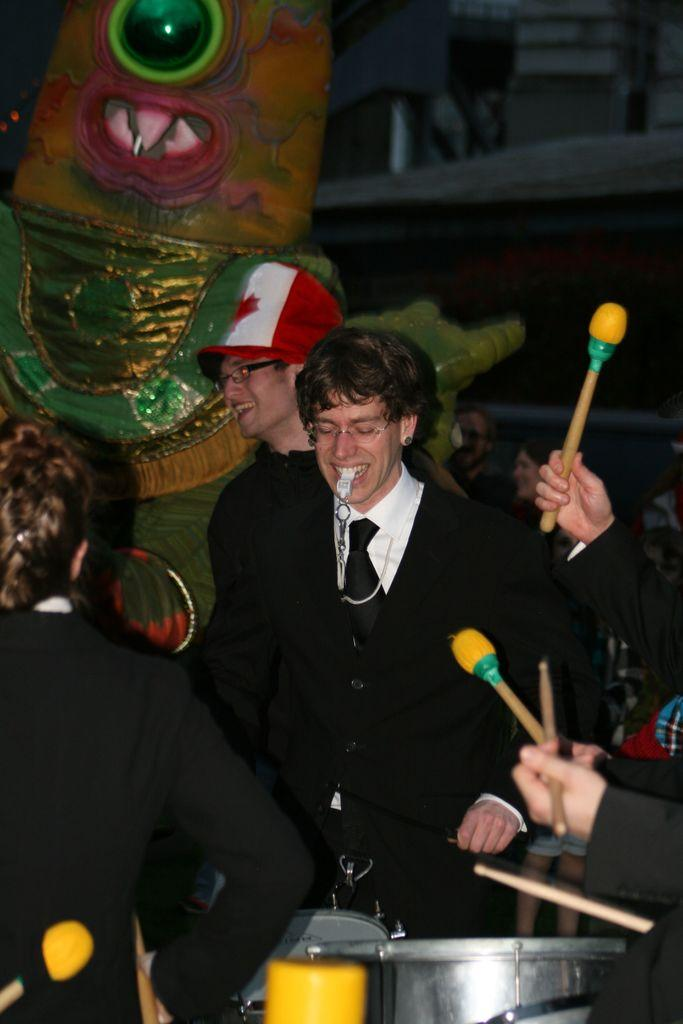Who or what can be seen in the image? There are people in the image. What are some of the people holding? Some of the people are holding drumsticks. What objects are in front of the people? There are drums in front of the people. What can be seen in the distance behind the people? There is a sculpture and a building in the background of the image. What type of needle is being used by the people in the image? There is no needle present in the image; the people are holding drumsticks and playing drums. 